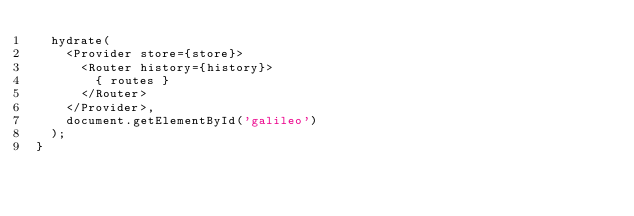Convert code to text. <code><loc_0><loc_0><loc_500><loc_500><_JavaScript_>  hydrate(
    <Provider store={store}>
      <Router history={history}>
        { routes }
      </Router>
    </Provider>,
    document.getElementById('galileo')
  );
}
</code> 